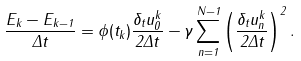Convert formula to latex. <formula><loc_0><loc_0><loc_500><loc_500>\frac { E _ { k } - E _ { k - 1 } } { \Delta t } = \phi ( t _ { k } ) \frac { \delta _ { t } u _ { 0 } ^ { k } } { 2 \Delta t } - \gamma \sum _ { n = 1 } ^ { N - 1 } \left ( \frac { \delta _ { t } u _ { n } ^ { k } } { 2 \Delta t } \right ) ^ { 2 } .</formula> 